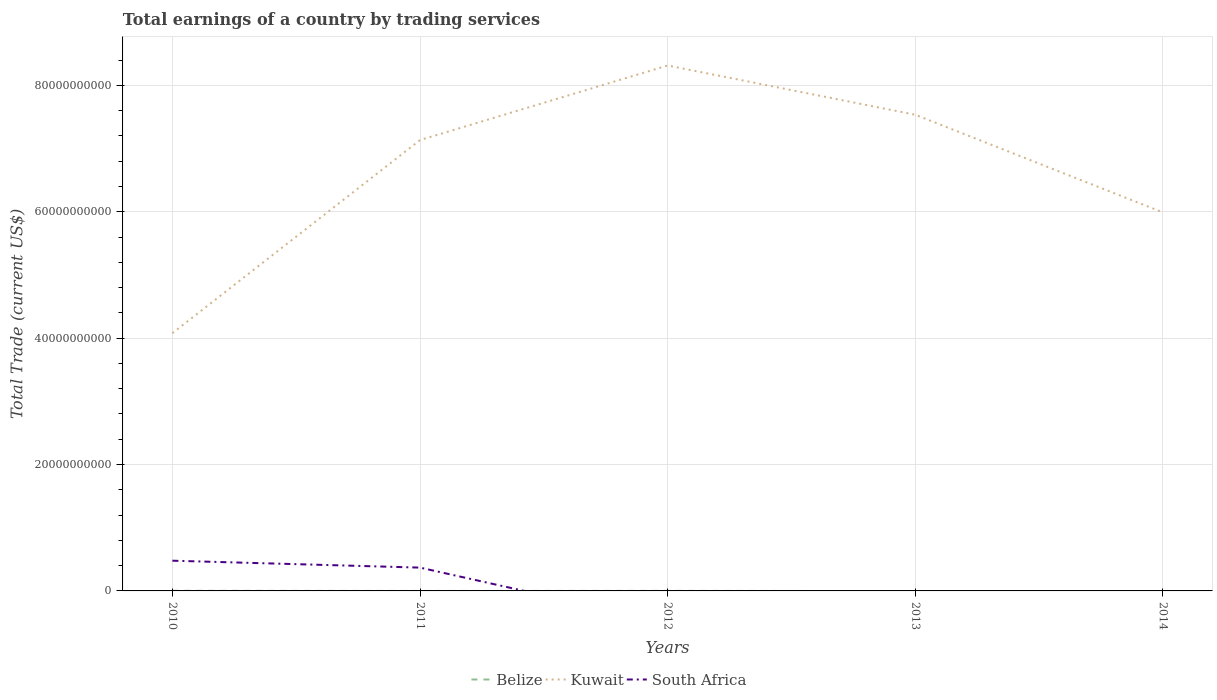Is the number of lines equal to the number of legend labels?
Offer a terse response. No. What is the total total earnings in Kuwait in the graph?
Your answer should be very brief. -4.00e+09. What is the difference between the highest and the second highest total earnings in South Africa?
Your answer should be very brief. 4.78e+09. What is the difference between the highest and the lowest total earnings in Kuwait?
Ensure brevity in your answer.  3. Is the total earnings in Belize strictly greater than the total earnings in South Africa over the years?
Ensure brevity in your answer.  No. How many lines are there?
Offer a very short reply. 3. How many years are there in the graph?
Offer a terse response. 5. What is the difference between two consecutive major ticks on the Y-axis?
Ensure brevity in your answer.  2.00e+1. Does the graph contain any zero values?
Your answer should be compact. Yes. How are the legend labels stacked?
Provide a short and direct response. Horizontal. What is the title of the graph?
Offer a very short reply. Total earnings of a country by trading services. Does "Oman" appear as one of the legend labels in the graph?
Give a very brief answer. No. What is the label or title of the Y-axis?
Offer a very short reply. Total Trade (current US$). What is the Total Trade (current US$) in Belize in 2010?
Keep it short and to the point. 2.00e+07. What is the Total Trade (current US$) of Kuwait in 2010?
Provide a short and direct response. 4.08e+1. What is the Total Trade (current US$) in South Africa in 2010?
Your response must be concise. 4.78e+09. What is the Total Trade (current US$) of Belize in 2011?
Give a very brief answer. 0. What is the Total Trade (current US$) of Kuwait in 2011?
Provide a succinct answer. 7.13e+1. What is the Total Trade (current US$) in South Africa in 2011?
Provide a short and direct response. 3.69e+09. What is the Total Trade (current US$) of Belize in 2012?
Give a very brief answer. 9.36e+06. What is the Total Trade (current US$) in Kuwait in 2012?
Make the answer very short. 8.31e+1. What is the Total Trade (current US$) in Kuwait in 2013?
Keep it short and to the point. 7.53e+1. What is the Total Trade (current US$) in South Africa in 2013?
Keep it short and to the point. 0. What is the Total Trade (current US$) in Kuwait in 2014?
Your answer should be very brief. 5.99e+1. Across all years, what is the maximum Total Trade (current US$) of Belize?
Make the answer very short. 2.00e+07. Across all years, what is the maximum Total Trade (current US$) in Kuwait?
Ensure brevity in your answer.  8.31e+1. Across all years, what is the maximum Total Trade (current US$) of South Africa?
Keep it short and to the point. 4.78e+09. Across all years, what is the minimum Total Trade (current US$) in Belize?
Your answer should be compact. 0. Across all years, what is the minimum Total Trade (current US$) of Kuwait?
Your response must be concise. 4.08e+1. What is the total Total Trade (current US$) in Belize in the graph?
Make the answer very short. 2.93e+07. What is the total Total Trade (current US$) in Kuwait in the graph?
Provide a succinct answer. 3.31e+11. What is the total Total Trade (current US$) in South Africa in the graph?
Provide a succinct answer. 8.47e+09. What is the difference between the Total Trade (current US$) in Kuwait in 2010 and that in 2011?
Keep it short and to the point. -3.06e+1. What is the difference between the Total Trade (current US$) of South Africa in 2010 and that in 2011?
Offer a very short reply. 1.09e+09. What is the difference between the Total Trade (current US$) of Belize in 2010 and that in 2012?
Make the answer very short. 1.06e+07. What is the difference between the Total Trade (current US$) of Kuwait in 2010 and that in 2012?
Your response must be concise. -4.24e+1. What is the difference between the Total Trade (current US$) of Kuwait in 2010 and that in 2013?
Ensure brevity in your answer.  -3.46e+1. What is the difference between the Total Trade (current US$) of Kuwait in 2010 and that in 2014?
Your answer should be very brief. -1.91e+1. What is the difference between the Total Trade (current US$) of Kuwait in 2011 and that in 2012?
Offer a very short reply. -1.18e+1. What is the difference between the Total Trade (current US$) of Kuwait in 2011 and that in 2013?
Make the answer very short. -4.00e+09. What is the difference between the Total Trade (current US$) of Kuwait in 2011 and that in 2014?
Your answer should be very brief. 1.15e+1. What is the difference between the Total Trade (current US$) of Kuwait in 2012 and that in 2013?
Your answer should be compact. 7.80e+09. What is the difference between the Total Trade (current US$) in Kuwait in 2012 and that in 2014?
Your answer should be compact. 2.33e+1. What is the difference between the Total Trade (current US$) in Kuwait in 2013 and that in 2014?
Your answer should be compact. 1.55e+1. What is the difference between the Total Trade (current US$) of Belize in 2010 and the Total Trade (current US$) of Kuwait in 2011?
Provide a short and direct response. -7.13e+1. What is the difference between the Total Trade (current US$) of Belize in 2010 and the Total Trade (current US$) of South Africa in 2011?
Provide a short and direct response. -3.67e+09. What is the difference between the Total Trade (current US$) in Kuwait in 2010 and the Total Trade (current US$) in South Africa in 2011?
Your answer should be compact. 3.71e+1. What is the difference between the Total Trade (current US$) of Belize in 2010 and the Total Trade (current US$) of Kuwait in 2012?
Offer a terse response. -8.31e+1. What is the difference between the Total Trade (current US$) in Belize in 2010 and the Total Trade (current US$) in Kuwait in 2013?
Make the answer very short. -7.53e+1. What is the difference between the Total Trade (current US$) in Belize in 2010 and the Total Trade (current US$) in Kuwait in 2014?
Ensure brevity in your answer.  -5.99e+1. What is the difference between the Total Trade (current US$) in Belize in 2012 and the Total Trade (current US$) in Kuwait in 2013?
Offer a very short reply. -7.53e+1. What is the difference between the Total Trade (current US$) in Belize in 2012 and the Total Trade (current US$) in Kuwait in 2014?
Keep it short and to the point. -5.99e+1. What is the average Total Trade (current US$) in Belize per year?
Make the answer very short. 5.86e+06. What is the average Total Trade (current US$) of Kuwait per year?
Provide a succinct answer. 6.61e+1. What is the average Total Trade (current US$) of South Africa per year?
Your answer should be compact. 1.69e+09. In the year 2010, what is the difference between the Total Trade (current US$) of Belize and Total Trade (current US$) of Kuwait?
Offer a very short reply. -4.08e+1. In the year 2010, what is the difference between the Total Trade (current US$) in Belize and Total Trade (current US$) in South Africa?
Make the answer very short. -4.76e+09. In the year 2010, what is the difference between the Total Trade (current US$) in Kuwait and Total Trade (current US$) in South Africa?
Ensure brevity in your answer.  3.60e+1. In the year 2011, what is the difference between the Total Trade (current US$) of Kuwait and Total Trade (current US$) of South Africa?
Keep it short and to the point. 6.77e+1. In the year 2012, what is the difference between the Total Trade (current US$) of Belize and Total Trade (current US$) of Kuwait?
Make the answer very short. -8.31e+1. What is the ratio of the Total Trade (current US$) in Kuwait in 2010 to that in 2011?
Make the answer very short. 0.57. What is the ratio of the Total Trade (current US$) in South Africa in 2010 to that in 2011?
Your answer should be very brief. 1.3. What is the ratio of the Total Trade (current US$) in Belize in 2010 to that in 2012?
Your answer should be very brief. 2.13. What is the ratio of the Total Trade (current US$) of Kuwait in 2010 to that in 2012?
Your answer should be compact. 0.49. What is the ratio of the Total Trade (current US$) in Kuwait in 2010 to that in 2013?
Provide a short and direct response. 0.54. What is the ratio of the Total Trade (current US$) of Kuwait in 2010 to that in 2014?
Give a very brief answer. 0.68. What is the ratio of the Total Trade (current US$) in Kuwait in 2011 to that in 2012?
Provide a short and direct response. 0.86. What is the ratio of the Total Trade (current US$) of Kuwait in 2011 to that in 2013?
Give a very brief answer. 0.95. What is the ratio of the Total Trade (current US$) of Kuwait in 2011 to that in 2014?
Offer a terse response. 1.19. What is the ratio of the Total Trade (current US$) in Kuwait in 2012 to that in 2013?
Ensure brevity in your answer.  1.1. What is the ratio of the Total Trade (current US$) in Kuwait in 2012 to that in 2014?
Offer a terse response. 1.39. What is the ratio of the Total Trade (current US$) in Kuwait in 2013 to that in 2014?
Ensure brevity in your answer.  1.26. What is the difference between the highest and the second highest Total Trade (current US$) in Kuwait?
Your response must be concise. 7.80e+09. What is the difference between the highest and the lowest Total Trade (current US$) in Belize?
Provide a short and direct response. 2.00e+07. What is the difference between the highest and the lowest Total Trade (current US$) in Kuwait?
Ensure brevity in your answer.  4.24e+1. What is the difference between the highest and the lowest Total Trade (current US$) of South Africa?
Keep it short and to the point. 4.78e+09. 